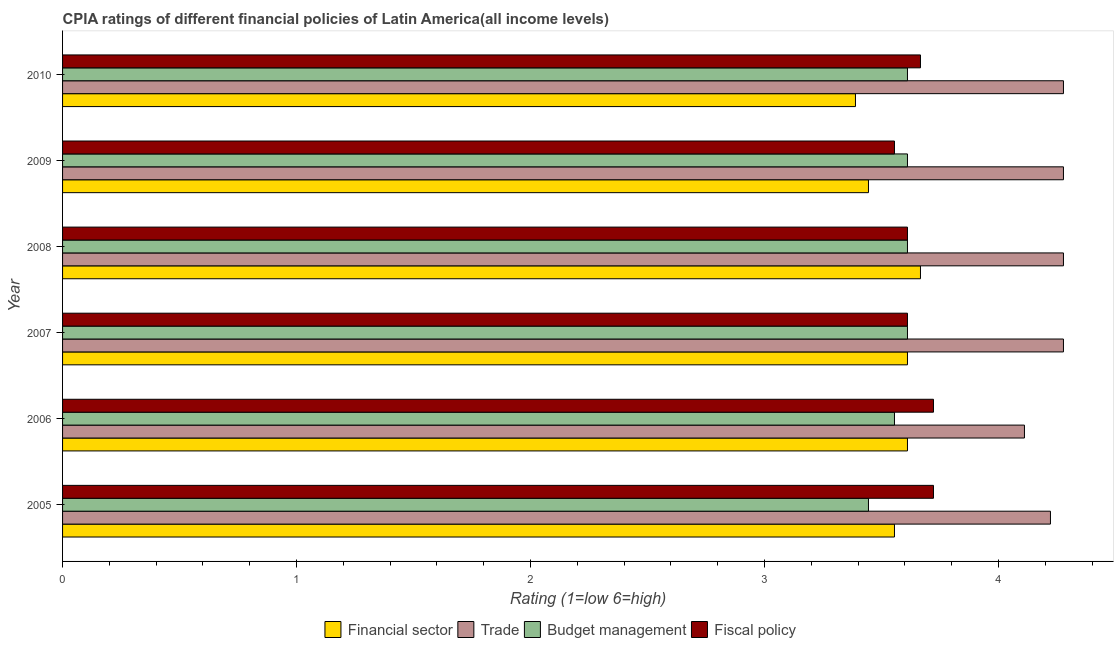Are the number of bars per tick equal to the number of legend labels?
Your response must be concise. Yes. Are the number of bars on each tick of the Y-axis equal?
Ensure brevity in your answer.  Yes. What is the label of the 2nd group of bars from the top?
Your response must be concise. 2009. In how many cases, is the number of bars for a given year not equal to the number of legend labels?
Give a very brief answer. 0. What is the cpia rating of trade in 2009?
Offer a very short reply. 4.28. Across all years, what is the maximum cpia rating of trade?
Your response must be concise. 4.28. Across all years, what is the minimum cpia rating of trade?
Give a very brief answer. 4.11. In which year was the cpia rating of budget management maximum?
Your answer should be very brief. 2007. In which year was the cpia rating of fiscal policy minimum?
Provide a short and direct response. 2009. What is the total cpia rating of fiscal policy in the graph?
Your response must be concise. 21.89. What is the difference between the cpia rating of trade in 2005 and that in 2008?
Your response must be concise. -0.06. What is the difference between the cpia rating of fiscal policy in 2009 and the cpia rating of trade in 2010?
Offer a terse response. -0.72. What is the average cpia rating of fiscal policy per year?
Your answer should be compact. 3.65. In the year 2009, what is the difference between the cpia rating of fiscal policy and cpia rating of financial sector?
Your answer should be very brief. 0.11. What is the ratio of the cpia rating of fiscal policy in 2008 to that in 2009?
Give a very brief answer. 1.02. Is the cpia rating of fiscal policy in 2005 less than that in 2007?
Keep it short and to the point. No. Is the difference between the cpia rating of budget management in 2006 and 2007 greater than the difference between the cpia rating of trade in 2006 and 2007?
Your answer should be compact. Yes. What is the difference between the highest and the second highest cpia rating of budget management?
Ensure brevity in your answer.  0. What is the difference between the highest and the lowest cpia rating of trade?
Offer a terse response. 0.17. In how many years, is the cpia rating of financial sector greater than the average cpia rating of financial sector taken over all years?
Offer a terse response. 4. What does the 4th bar from the top in 2008 represents?
Give a very brief answer. Financial sector. What does the 3rd bar from the bottom in 2010 represents?
Your answer should be compact. Budget management. Is it the case that in every year, the sum of the cpia rating of financial sector and cpia rating of trade is greater than the cpia rating of budget management?
Make the answer very short. Yes. Are all the bars in the graph horizontal?
Make the answer very short. Yes. Does the graph contain any zero values?
Make the answer very short. No. Does the graph contain grids?
Ensure brevity in your answer.  No. Where does the legend appear in the graph?
Your response must be concise. Bottom center. How many legend labels are there?
Provide a short and direct response. 4. What is the title of the graph?
Offer a very short reply. CPIA ratings of different financial policies of Latin America(all income levels). Does "Other Minerals" appear as one of the legend labels in the graph?
Your answer should be very brief. No. What is the label or title of the X-axis?
Provide a succinct answer. Rating (1=low 6=high). What is the Rating (1=low 6=high) in Financial sector in 2005?
Keep it short and to the point. 3.56. What is the Rating (1=low 6=high) in Trade in 2005?
Your answer should be very brief. 4.22. What is the Rating (1=low 6=high) in Budget management in 2005?
Your answer should be compact. 3.44. What is the Rating (1=low 6=high) of Fiscal policy in 2005?
Your answer should be compact. 3.72. What is the Rating (1=low 6=high) of Financial sector in 2006?
Provide a succinct answer. 3.61. What is the Rating (1=low 6=high) of Trade in 2006?
Provide a short and direct response. 4.11. What is the Rating (1=low 6=high) of Budget management in 2006?
Give a very brief answer. 3.56. What is the Rating (1=low 6=high) in Fiscal policy in 2006?
Give a very brief answer. 3.72. What is the Rating (1=low 6=high) in Financial sector in 2007?
Your answer should be very brief. 3.61. What is the Rating (1=low 6=high) of Trade in 2007?
Your answer should be compact. 4.28. What is the Rating (1=low 6=high) in Budget management in 2007?
Make the answer very short. 3.61. What is the Rating (1=low 6=high) of Fiscal policy in 2007?
Ensure brevity in your answer.  3.61. What is the Rating (1=low 6=high) of Financial sector in 2008?
Provide a short and direct response. 3.67. What is the Rating (1=low 6=high) of Trade in 2008?
Your response must be concise. 4.28. What is the Rating (1=low 6=high) in Budget management in 2008?
Ensure brevity in your answer.  3.61. What is the Rating (1=low 6=high) in Fiscal policy in 2008?
Offer a terse response. 3.61. What is the Rating (1=low 6=high) in Financial sector in 2009?
Your answer should be very brief. 3.44. What is the Rating (1=low 6=high) in Trade in 2009?
Your response must be concise. 4.28. What is the Rating (1=low 6=high) in Budget management in 2009?
Offer a terse response. 3.61. What is the Rating (1=low 6=high) of Fiscal policy in 2009?
Offer a terse response. 3.56. What is the Rating (1=low 6=high) of Financial sector in 2010?
Give a very brief answer. 3.39. What is the Rating (1=low 6=high) in Trade in 2010?
Your response must be concise. 4.28. What is the Rating (1=low 6=high) of Budget management in 2010?
Ensure brevity in your answer.  3.61. What is the Rating (1=low 6=high) of Fiscal policy in 2010?
Your answer should be very brief. 3.67. Across all years, what is the maximum Rating (1=low 6=high) of Financial sector?
Ensure brevity in your answer.  3.67. Across all years, what is the maximum Rating (1=low 6=high) in Trade?
Provide a short and direct response. 4.28. Across all years, what is the maximum Rating (1=low 6=high) of Budget management?
Your answer should be compact. 3.61. Across all years, what is the maximum Rating (1=low 6=high) of Fiscal policy?
Your answer should be very brief. 3.72. Across all years, what is the minimum Rating (1=low 6=high) in Financial sector?
Your answer should be compact. 3.39. Across all years, what is the minimum Rating (1=low 6=high) in Trade?
Keep it short and to the point. 4.11. Across all years, what is the minimum Rating (1=low 6=high) in Budget management?
Offer a very short reply. 3.44. Across all years, what is the minimum Rating (1=low 6=high) of Fiscal policy?
Your answer should be very brief. 3.56. What is the total Rating (1=low 6=high) in Financial sector in the graph?
Your response must be concise. 21.28. What is the total Rating (1=low 6=high) of Trade in the graph?
Offer a very short reply. 25.44. What is the total Rating (1=low 6=high) of Budget management in the graph?
Your answer should be very brief. 21.44. What is the total Rating (1=low 6=high) of Fiscal policy in the graph?
Ensure brevity in your answer.  21.89. What is the difference between the Rating (1=low 6=high) in Financial sector in 2005 and that in 2006?
Your answer should be very brief. -0.06. What is the difference between the Rating (1=low 6=high) in Budget management in 2005 and that in 2006?
Ensure brevity in your answer.  -0.11. What is the difference between the Rating (1=low 6=high) in Financial sector in 2005 and that in 2007?
Offer a terse response. -0.06. What is the difference between the Rating (1=low 6=high) in Trade in 2005 and that in 2007?
Offer a very short reply. -0.06. What is the difference between the Rating (1=low 6=high) in Financial sector in 2005 and that in 2008?
Provide a short and direct response. -0.11. What is the difference between the Rating (1=low 6=high) of Trade in 2005 and that in 2008?
Provide a short and direct response. -0.06. What is the difference between the Rating (1=low 6=high) of Fiscal policy in 2005 and that in 2008?
Offer a terse response. 0.11. What is the difference between the Rating (1=low 6=high) in Financial sector in 2005 and that in 2009?
Provide a succinct answer. 0.11. What is the difference between the Rating (1=low 6=high) in Trade in 2005 and that in 2009?
Your response must be concise. -0.06. What is the difference between the Rating (1=low 6=high) of Fiscal policy in 2005 and that in 2009?
Your answer should be very brief. 0.17. What is the difference between the Rating (1=low 6=high) of Trade in 2005 and that in 2010?
Give a very brief answer. -0.06. What is the difference between the Rating (1=low 6=high) in Budget management in 2005 and that in 2010?
Your answer should be very brief. -0.17. What is the difference between the Rating (1=low 6=high) in Fiscal policy in 2005 and that in 2010?
Keep it short and to the point. 0.06. What is the difference between the Rating (1=low 6=high) of Budget management in 2006 and that in 2007?
Offer a terse response. -0.06. What is the difference between the Rating (1=low 6=high) in Financial sector in 2006 and that in 2008?
Provide a succinct answer. -0.06. What is the difference between the Rating (1=low 6=high) of Trade in 2006 and that in 2008?
Make the answer very short. -0.17. What is the difference between the Rating (1=low 6=high) of Budget management in 2006 and that in 2008?
Your response must be concise. -0.06. What is the difference between the Rating (1=low 6=high) of Budget management in 2006 and that in 2009?
Provide a succinct answer. -0.06. What is the difference between the Rating (1=low 6=high) of Fiscal policy in 2006 and that in 2009?
Offer a terse response. 0.17. What is the difference between the Rating (1=low 6=high) in Financial sector in 2006 and that in 2010?
Keep it short and to the point. 0.22. What is the difference between the Rating (1=low 6=high) of Trade in 2006 and that in 2010?
Provide a short and direct response. -0.17. What is the difference between the Rating (1=low 6=high) in Budget management in 2006 and that in 2010?
Offer a very short reply. -0.06. What is the difference between the Rating (1=low 6=high) in Fiscal policy in 2006 and that in 2010?
Ensure brevity in your answer.  0.06. What is the difference between the Rating (1=low 6=high) of Financial sector in 2007 and that in 2008?
Your answer should be compact. -0.06. What is the difference between the Rating (1=low 6=high) of Fiscal policy in 2007 and that in 2009?
Offer a terse response. 0.06. What is the difference between the Rating (1=low 6=high) in Financial sector in 2007 and that in 2010?
Your answer should be very brief. 0.22. What is the difference between the Rating (1=low 6=high) in Fiscal policy in 2007 and that in 2010?
Offer a very short reply. -0.06. What is the difference between the Rating (1=low 6=high) of Financial sector in 2008 and that in 2009?
Offer a very short reply. 0.22. What is the difference between the Rating (1=low 6=high) of Trade in 2008 and that in 2009?
Offer a terse response. 0. What is the difference between the Rating (1=low 6=high) in Budget management in 2008 and that in 2009?
Make the answer very short. 0. What is the difference between the Rating (1=low 6=high) of Fiscal policy in 2008 and that in 2009?
Provide a succinct answer. 0.06. What is the difference between the Rating (1=low 6=high) in Financial sector in 2008 and that in 2010?
Provide a short and direct response. 0.28. What is the difference between the Rating (1=low 6=high) in Fiscal policy in 2008 and that in 2010?
Offer a terse response. -0.06. What is the difference between the Rating (1=low 6=high) of Financial sector in 2009 and that in 2010?
Offer a very short reply. 0.06. What is the difference between the Rating (1=low 6=high) of Trade in 2009 and that in 2010?
Keep it short and to the point. 0. What is the difference between the Rating (1=low 6=high) of Fiscal policy in 2009 and that in 2010?
Offer a terse response. -0.11. What is the difference between the Rating (1=low 6=high) in Financial sector in 2005 and the Rating (1=low 6=high) in Trade in 2006?
Give a very brief answer. -0.56. What is the difference between the Rating (1=low 6=high) in Financial sector in 2005 and the Rating (1=low 6=high) in Budget management in 2006?
Give a very brief answer. 0. What is the difference between the Rating (1=low 6=high) of Trade in 2005 and the Rating (1=low 6=high) of Budget management in 2006?
Provide a short and direct response. 0.67. What is the difference between the Rating (1=low 6=high) in Budget management in 2005 and the Rating (1=low 6=high) in Fiscal policy in 2006?
Keep it short and to the point. -0.28. What is the difference between the Rating (1=low 6=high) in Financial sector in 2005 and the Rating (1=low 6=high) in Trade in 2007?
Provide a succinct answer. -0.72. What is the difference between the Rating (1=low 6=high) in Financial sector in 2005 and the Rating (1=low 6=high) in Budget management in 2007?
Your answer should be very brief. -0.06. What is the difference between the Rating (1=low 6=high) in Financial sector in 2005 and the Rating (1=low 6=high) in Fiscal policy in 2007?
Your response must be concise. -0.06. What is the difference between the Rating (1=low 6=high) in Trade in 2005 and the Rating (1=low 6=high) in Budget management in 2007?
Your response must be concise. 0.61. What is the difference between the Rating (1=low 6=high) of Trade in 2005 and the Rating (1=low 6=high) of Fiscal policy in 2007?
Provide a succinct answer. 0.61. What is the difference between the Rating (1=low 6=high) of Financial sector in 2005 and the Rating (1=low 6=high) of Trade in 2008?
Make the answer very short. -0.72. What is the difference between the Rating (1=low 6=high) in Financial sector in 2005 and the Rating (1=low 6=high) in Budget management in 2008?
Provide a succinct answer. -0.06. What is the difference between the Rating (1=low 6=high) of Financial sector in 2005 and the Rating (1=low 6=high) of Fiscal policy in 2008?
Ensure brevity in your answer.  -0.06. What is the difference between the Rating (1=low 6=high) of Trade in 2005 and the Rating (1=low 6=high) of Budget management in 2008?
Your answer should be compact. 0.61. What is the difference between the Rating (1=low 6=high) of Trade in 2005 and the Rating (1=low 6=high) of Fiscal policy in 2008?
Make the answer very short. 0.61. What is the difference between the Rating (1=low 6=high) of Financial sector in 2005 and the Rating (1=low 6=high) of Trade in 2009?
Provide a short and direct response. -0.72. What is the difference between the Rating (1=low 6=high) in Financial sector in 2005 and the Rating (1=low 6=high) in Budget management in 2009?
Your answer should be compact. -0.06. What is the difference between the Rating (1=low 6=high) in Trade in 2005 and the Rating (1=low 6=high) in Budget management in 2009?
Offer a terse response. 0.61. What is the difference between the Rating (1=low 6=high) in Trade in 2005 and the Rating (1=low 6=high) in Fiscal policy in 2009?
Make the answer very short. 0.67. What is the difference between the Rating (1=low 6=high) in Budget management in 2005 and the Rating (1=low 6=high) in Fiscal policy in 2009?
Keep it short and to the point. -0.11. What is the difference between the Rating (1=low 6=high) of Financial sector in 2005 and the Rating (1=low 6=high) of Trade in 2010?
Your answer should be compact. -0.72. What is the difference between the Rating (1=low 6=high) of Financial sector in 2005 and the Rating (1=low 6=high) of Budget management in 2010?
Provide a short and direct response. -0.06. What is the difference between the Rating (1=low 6=high) in Financial sector in 2005 and the Rating (1=low 6=high) in Fiscal policy in 2010?
Offer a very short reply. -0.11. What is the difference between the Rating (1=low 6=high) of Trade in 2005 and the Rating (1=low 6=high) of Budget management in 2010?
Provide a short and direct response. 0.61. What is the difference between the Rating (1=low 6=high) in Trade in 2005 and the Rating (1=low 6=high) in Fiscal policy in 2010?
Make the answer very short. 0.56. What is the difference between the Rating (1=low 6=high) in Budget management in 2005 and the Rating (1=low 6=high) in Fiscal policy in 2010?
Ensure brevity in your answer.  -0.22. What is the difference between the Rating (1=low 6=high) in Financial sector in 2006 and the Rating (1=low 6=high) in Budget management in 2007?
Your answer should be very brief. 0. What is the difference between the Rating (1=low 6=high) in Trade in 2006 and the Rating (1=low 6=high) in Fiscal policy in 2007?
Make the answer very short. 0.5. What is the difference between the Rating (1=low 6=high) in Budget management in 2006 and the Rating (1=low 6=high) in Fiscal policy in 2007?
Offer a very short reply. -0.06. What is the difference between the Rating (1=low 6=high) in Financial sector in 2006 and the Rating (1=low 6=high) in Trade in 2008?
Ensure brevity in your answer.  -0.67. What is the difference between the Rating (1=low 6=high) in Trade in 2006 and the Rating (1=low 6=high) in Budget management in 2008?
Give a very brief answer. 0.5. What is the difference between the Rating (1=low 6=high) of Trade in 2006 and the Rating (1=low 6=high) of Fiscal policy in 2008?
Keep it short and to the point. 0.5. What is the difference between the Rating (1=low 6=high) of Budget management in 2006 and the Rating (1=low 6=high) of Fiscal policy in 2008?
Your answer should be compact. -0.06. What is the difference between the Rating (1=low 6=high) in Financial sector in 2006 and the Rating (1=low 6=high) in Trade in 2009?
Offer a very short reply. -0.67. What is the difference between the Rating (1=low 6=high) in Financial sector in 2006 and the Rating (1=low 6=high) in Fiscal policy in 2009?
Give a very brief answer. 0.06. What is the difference between the Rating (1=low 6=high) in Trade in 2006 and the Rating (1=low 6=high) in Budget management in 2009?
Provide a succinct answer. 0.5. What is the difference between the Rating (1=low 6=high) of Trade in 2006 and the Rating (1=low 6=high) of Fiscal policy in 2009?
Provide a short and direct response. 0.56. What is the difference between the Rating (1=low 6=high) in Financial sector in 2006 and the Rating (1=low 6=high) in Trade in 2010?
Offer a terse response. -0.67. What is the difference between the Rating (1=low 6=high) in Financial sector in 2006 and the Rating (1=low 6=high) in Budget management in 2010?
Provide a short and direct response. 0. What is the difference between the Rating (1=low 6=high) of Financial sector in 2006 and the Rating (1=low 6=high) of Fiscal policy in 2010?
Your answer should be very brief. -0.06. What is the difference between the Rating (1=low 6=high) in Trade in 2006 and the Rating (1=low 6=high) in Fiscal policy in 2010?
Your answer should be compact. 0.44. What is the difference between the Rating (1=low 6=high) in Budget management in 2006 and the Rating (1=low 6=high) in Fiscal policy in 2010?
Make the answer very short. -0.11. What is the difference between the Rating (1=low 6=high) of Financial sector in 2007 and the Rating (1=low 6=high) of Budget management in 2008?
Your answer should be compact. 0. What is the difference between the Rating (1=low 6=high) of Trade in 2007 and the Rating (1=low 6=high) of Budget management in 2008?
Your response must be concise. 0.67. What is the difference between the Rating (1=low 6=high) in Trade in 2007 and the Rating (1=low 6=high) in Fiscal policy in 2008?
Make the answer very short. 0.67. What is the difference between the Rating (1=low 6=high) in Budget management in 2007 and the Rating (1=low 6=high) in Fiscal policy in 2008?
Offer a very short reply. 0. What is the difference between the Rating (1=low 6=high) in Financial sector in 2007 and the Rating (1=low 6=high) in Fiscal policy in 2009?
Provide a succinct answer. 0.06. What is the difference between the Rating (1=low 6=high) of Trade in 2007 and the Rating (1=low 6=high) of Fiscal policy in 2009?
Provide a succinct answer. 0.72. What is the difference between the Rating (1=low 6=high) in Budget management in 2007 and the Rating (1=low 6=high) in Fiscal policy in 2009?
Make the answer very short. 0.06. What is the difference between the Rating (1=low 6=high) of Financial sector in 2007 and the Rating (1=low 6=high) of Budget management in 2010?
Offer a terse response. 0. What is the difference between the Rating (1=low 6=high) of Financial sector in 2007 and the Rating (1=low 6=high) of Fiscal policy in 2010?
Your response must be concise. -0.06. What is the difference between the Rating (1=low 6=high) in Trade in 2007 and the Rating (1=low 6=high) in Fiscal policy in 2010?
Provide a succinct answer. 0.61. What is the difference between the Rating (1=low 6=high) of Budget management in 2007 and the Rating (1=low 6=high) of Fiscal policy in 2010?
Your answer should be very brief. -0.06. What is the difference between the Rating (1=low 6=high) of Financial sector in 2008 and the Rating (1=low 6=high) of Trade in 2009?
Offer a terse response. -0.61. What is the difference between the Rating (1=low 6=high) in Financial sector in 2008 and the Rating (1=low 6=high) in Budget management in 2009?
Make the answer very short. 0.06. What is the difference between the Rating (1=low 6=high) in Trade in 2008 and the Rating (1=low 6=high) in Fiscal policy in 2009?
Offer a very short reply. 0.72. What is the difference between the Rating (1=low 6=high) in Budget management in 2008 and the Rating (1=low 6=high) in Fiscal policy in 2009?
Make the answer very short. 0.06. What is the difference between the Rating (1=low 6=high) of Financial sector in 2008 and the Rating (1=low 6=high) of Trade in 2010?
Provide a succinct answer. -0.61. What is the difference between the Rating (1=low 6=high) in Financial sector in 2008 and the Rating (1=low 6=high) in Budget management in 2010?
Provide a short and direct response. 0.06. What is the difference between the Rating (1=low 6=high) of Financial sector in 2008 and the Rating (1=low 6=high) of Fiscal policy in 2010?
Keep it short and to the point. 0. What is the difference between the Rating (1=low 6=high) of Trade in 2008 and the Rating (1=low 6=high) of Budget management in 2010?
Your response must be concise. 0.67. What is the difference between the Rating (1=low 6=high) of Trade in 2008 and the Rating (1=low 6=high) of Fiscal policy in 2010?
Give a very brief answer. 0.61. What is the difference between the Rating (1=low 6=high) in Budget management in 2008 and the Rating (1=low 6=high) in Fiscal policy in 2010?
Make the answer very short. -0.06. What is the difference between the Rating (1=low 6=high) of Financial sector in 2009 and the Rating (1=low 6=high) of Budget management in 2010?
Your answer should be very brief. -0.17. What is the difference between the Rating (1=low 6=high) in Financial sector in 2009 and the Rating (1=low 6=high) in Fiscal policy in 2010?
Ensure brevity in your answer.  -0.22. What is the difference between the Rating (1=low 6=high) of Trade in 2009 and the Rating (1=low 6=high) of Fiscal policy in 2010?
Your response must be concise. 0.61. What is the difference between the Rating (1=low 6=high) in Budget management in 2009 and the Rating (1=low 6=high) in Fiscal policy in 2010?
Keep it short and to the point. -0.06. What is the average Rating (1=low 6=high) in Financial sector per year?
Ensure brevity in your answer.  3.55. What is the average Rating (1=low 6=high) of Trade per year?
Offer a terse response. 4.24. What is the average Rating (1=low 6=high) in Budget management per year?
Make the answer very short. 3.57. What is the average Rating (1=low 6=high) of Fiscal policy per year?
Keep it short and to the point. 3.65. In the year 2005, what is the difference between the Rating (1=low 6=high) in Financial sector and Rating (1=low 6=high) in Fiscal policy?
Offer a very short reply. -0.17. In the year 2005, what is the difference between the Rating (1=low 6=high) of Trade and Rating (1=low 6=high) of Budget management?
Your response must be concise. 0.78. In the year 2005, what is the difference between the Rating (1=low 6=high) in Budget management and Rating (1=low 6=high) in Fiscal policy?
Provide a succinct answer. -0.28. In the year 2006, what is the difference between the Rating (1=low 6=high) of Financial sector and Rating (1=low 6=high) of Budget management?
Your answer should be very brief. 0.06. In the year 2006, what is the difference between the Rating (1=low 6=high) in Financial sector and Rating (1=low 6=high) in Fiscal policy?
Provide a succinct answer. -0.11. In the year 2006, what is the difference between the Rating (1=low 6=high) in Trade and Rating (1=low 6=high) in Budget management?
Your answer should be very brief. 0.56. In the year 2006, what is the difference between the Rating (1=low 6=high) of Trade and Rating (1=low 6=high) of Fiscal policy?
Ensure brevity in your answer.  0.39. In the year 2006, what is the difference between the Rating (1=low 6=high) in Budget management and Rating (1=low 6=high) in Fiscal policy?
Offer a very short reply. -0.17. In the year 2008, what is the difference between the Rating (1=low 6=high) of Financial sector and Rating (1=low 6=high) of Trade?
Give a very brief answer. -0.61. In the year 2008, what is the difference between the Rating (1=low 6=high) in Financial sector and Rating (1=low 6=high) in Budget management?
Give a very brief answer. 0.06. In the year 2008, what is the difference between the Rating (1=low 6=high) in Financial sector and Rating (1=low 6=high) in Fiscal policy?
Give a very brief answer. 0.06. In the year 2008, what is the difference between the Rating (1=low 6=high) of Trade and Rating (1=low 6=high) of Fiscal policy?
Give a very brief answer. 0.67. In the year 2008, what is the difference between the Rating (1=low 6=high) of Budget management and Rating (1=low 6=high) of Fiscal policy?
Your response must be concise. 0. In the year 2009, what is the difference between the Rating (1=low 6=high) of Financial sector and Rating (1=low 6=high) of Budget management?
Offer a terse response. -0.17. In the year 2009, what is the difference between the Rating (1=low 6=high) of Financial sector and Rating (1=low 6=high) of Fiscal policy?
Make the answer very short. -0.11. In the year 2009, what is the difference between the Rating (1=low 6=high) of Trade and Rating (1=low 6=high) of Fiscal policy?
Provide a short and direct response. 0.72. In the year 2009, what is the difference between the Rating (1=low 6=high) of Budget management and Rating (1=low 6=high) of Fiscal policy?
Give a very brief answer. 0.06. In the year 2010, what is the difference between the Rating (1=low 6=high) of Financial sector and Rating (1=low 6=high) of Trade?
Keep it short and to the point. -0.89. In the year 2010, what is the difference between the Rating (1=low 6=high) in Financial sector and Rating (1=low 6=high) in Budget management?
Ensure brevity in your answer.  -0.22. In the year 2010, what is the difference between the Rating (1=low 6=high) in Financial sector and Rating (1=low 6=high) in Fiscal policy?
Offer a very short reply. -0.28. In the year 2010, what is the difference between the Rating (1=low 6=high) of Trade and Rating (1=low 6=high) of Fiscal policy?
Your answer should be compact. 0.61. In the year 2010, what is the difference between the Rating (1=low 6=high) in Budget management and Rating (1=low 6=high) in Fiscal policy?
Keep it short and to the point. -0.06. What is the ratio of the Rating (1=low 6=high) of Financial sector in 2005 to that in 2006?
Your answer should be very brief. 0.98. What is the ratio of the Rating (1=low 6=high) of Trade in 2005 to that in 2006?
Ensure brevity in your answer.  1.03. What is the ratio of the Rating (1=low 6=high) of Budget management in 2005 to that in 2006?
Keep it short and to the point. 0.97. What is the ratio of the Rating (1=low 6=high) in Fiscal policy in 2005 to that in 2006?
Make the answer very short. 1. What is the ratio of the Rating (1=low 6=high) in Financial sector in 2005 to that in 2007?
Ensure brevity in your answer.  0.98. What is the ratio of the Rating (1=low 6=high) of Budget management in 2005 to that in 2007?
Keep it short and to the point. 0.95. What is the ratio of the Rating (1=low 6=high) of Fiscal policy in 2005 to that in 2007?
Provide a succinct answer. 1.03. What is the ratio of the Rating (1=low 6=high) in Financial sector in 2005 to that in 2008?
Give a very brief answer. 0.97. What is the ratio of the Rating (1=low 6=high) of Budget management in 2005 to that in 2008?
Provide a short and direct response. 0.95. What is the ratio of the Rating (1=low 6=high) of Fiscal policy in 2005 to that in 2008?
Provide a succinct answer. 1.03. What is the ratio of the Rating (1=low 6=high) of Financial sector in 2005 to that in 2009?
Give a very brief answer. 1.03. What is the ratio of the Rating (1=low 6=high) in Trade in 2005 to that in 2009?
Offer a very short reply. 0.99. What is the ratio of the Rating (1=low 6=high) of Budget management in 2005 to that in 2009?
Make the answer very short. 0.95. What is the ratio of the Rating (1=low 6=high) of Fiscal policy in 2005 to that in 2009?
Provide a short and direct response. 1.05. What is the ratio of the Rating (1=low 6=high) in Financial sector in 2005 to that in 2010?
Keep it short and to the point. 1.05. What is the ratio of the Rating (1=low 6=high) in Budget management in 2005 to that in 2010?
Your answer should be very brief. 0.95. What is the ratio of the Rating (1=low 6=high) in Fiscal policy in 2005 to that in 2010?
Provide a short and direct response. 1.02. What is the ratio of the Rating (1=low 6=high) of Financial sector in 2006 to that in 2007?
Ensure brevity in your answer.  1. What is the ratio of the Rating (1=low 6=high) in Budget management in 2006 to that in 2007?
Provide a succinct answer. 0.98. What is the ratio of the Rating (1=low 6=high) in Fiscal policy in 2006 to that in 2007?
Your answer should be very brief. 1.03. What is the ratio of the Rating (1=low 6=high) of Trade in 2006 to that in 2008?
Make the answer very short. 0.96. What is the ratio of the Rating (1=low 6=high) in Budget management in 2006 to that in 2008?
Your response must be concise. 0.98. What is the ratio of the Rating (1=low 6=high) in Fiscal policy in 2006 to that in 2008?
Keep it short and to the point. 1.03. What is the ratio of the Rating (1=low 6=high) in Financial sector in 2006 to that in 2009?
Your answer should be compact. 1.05. What is the ratio of the Rating (1=low 6=high) of Budget management in 2006 to that in 2009?
Your answer should be compact. 0.98. What is the ratio of the Rating (1=low 6=high) of Fiscal policy in 2006 to that in 2009?
Your answer should be very brief. 1.05. What is the ratio of the Rating (1=low 6=high) in Financial sector in 2006 to that in 2010?
Give a very brief answer. 1.07. What is the ratio of the Rating (1=low 6=high) in Trade in 2006 to that in 2010?
Ensure brevity in your answer.  0.96. What is the ratio of the Rating (1=low 6=high) in Budget management in 2006 to that in 2010?
Make the answer very short. 0.98. What is the ratio of the Rating (1=low 6=high) of Fiscal policy in 2006 to that in 2010?
Offer a terse response. 1.02. What is the ratio of the Rating (1=low 6=high) in Financial sector in 2007 to that in 2008?
Offer a terse response. 0.98. What is the ratio of the Rating (1=low 6=high) in Budget management in 2007 to that in 2008?
Your answer should be very brief. 1. What is the ratio of the Rating (1=low 6=high) of Financial sector in 2007 to that in 2009?
Ensure brevity in your answer.  1.05. What is the ratio of the Rating (1=low 6=high) in Budget management in 2007 to that in 2009?
Your answer should be very brief. 1. What is the ratio of the Rating (1=low 6=high) in Fiscal policy in 2007 to that in 2009?
Give a very brief answer. 1.02. What is the ratio of the Rating (1=low 6=high) in Financial sector in 2007 to that in 2010?
Make the answer very short. 1.07. What is the ratio of the Rating (1=low 6=high) of Trade in 2007 to that in 2010?
Your response must be concise. 1. What is the ratio of the Rating (1=low 6=high) in Financial sector in 2008 to that in 2009?
Your response must be concise. 1.06. What is the ratio of the Rating (1=low 6=high) in Trade in 2008 to that in 2009?
Offer a very short reply. 1. What is the ratio of the Rating (1=low 6=high) in Budget management in 2008 to that in 2009?
Your answer should be very brief. 1. What is the ratio of the Rating (1=low 6=high) in Fiscal policy in 2008 to that in 2009?
Offer a terse response. 1.02. What is the ratio of the Rating (1=low 6=high) in Financial sector in 2008 to that in 2010?
Offer a terse response. 1.08. What is the ratio of the Rating (1=low 6=high) of Trade in 2008 to that in 2010?
Your answer should be compact. 1. What is the ratio of the Rating (1=low 6=high) in Fiscal policy in 2008 to that in 2010?
Your answer should be compact. 0.98. What is the ratio of the Rating (1=low 6=high) in Financial sector in 2009 to that in 2010?
Your answer should be very brief. 1.02. What is the ratio of the Rating (1=low 6=high) in Budget management in 2009 to that in 2010?
Your answer should be very brief. 1. What is the ratio of the Rating (1=low 6=high) of Fiscal policy in 2009 to that in 2010?
Give a very brief answer. 0.97. What is the difference between the highest and the second highest Rating (1=low 6=high) of Financial sector?
Provide a short and direct response. 0.06. What is the difference between the highest and the second highest Rating (1=low 6=high) in Trade?
Your answer should be compact. 0. What is the difference between the highest and the second highest Rating (1=low 6=high) of Fiscal policy?
Your answer should be very brief. 0. What is the difference between the highest and the lowest Rating (1=low 6=high) in Financial sector?
Provide a short and direct response. 0.28. What is the difference between the highest and the lowest Rating (1=low 6=high) in Trade?
Offer a very short reply. 0.17. What is the difference between the highest and the lowest Rating (1=low 6=high) in Budget management?
Offer a very short reply. 0.17. What is the difference between the highest and the lowest Rating (1=low 6=high) of Fiscal policy?
Ensure brevity in your answer.  0.17. 